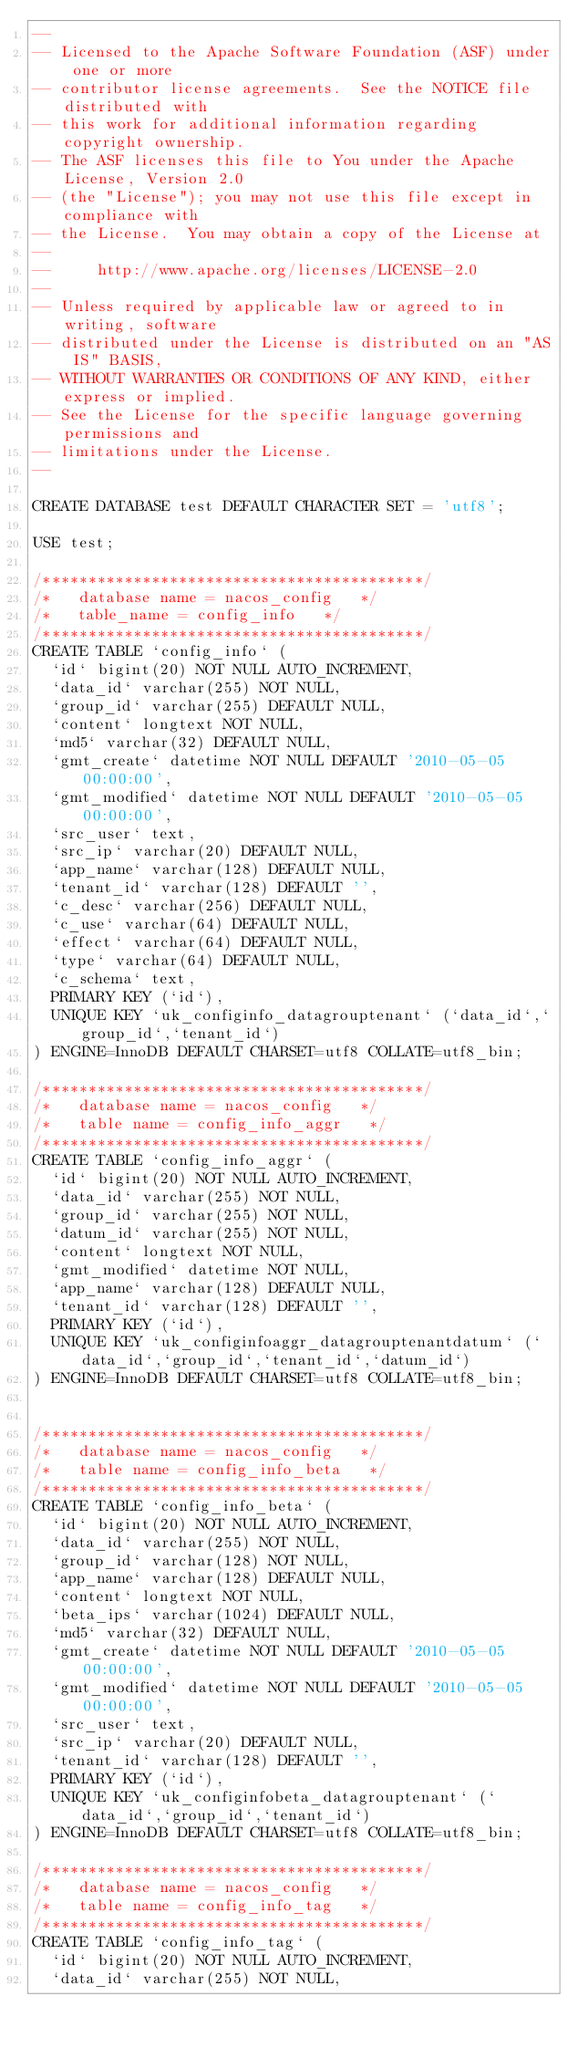<code> <loc_0><loc_0><loc_500><loc_500><_SQL_>--
-- Licensed to the Apache Software Foundation (ASF) under one or more
-- contributor license agreements.  See the NOTICE file distributed with
-- this work for additional information regarding copyright ownership.
-- The ASF licenses this file to You under the Apache License, Version 2.0
-- (the "License"); you may not use this file except in compliance with
-- the License.  You may obtain a copy of the License at
--
--     http://www.apache.org/licenses/LICENSE-2.0
--
-- Unless required by applicable law or agreed to in writing, software
-- distributed under the License is distributed on an "AS IS" BASIS,
-- WITHOUT WARRANTIES OR CONDITIONS OF ANY KIND, either express or implied.
-- See the License for the specific language governing permissions and
-- limitations under the License.
--

CREATE DATABASE test DEFAULT CHARACTER SET = 'utf8';

USE test;

/******************************************/
/*   database name = nacos_config   */
/*   table_name = config_info   */
/******************************************/
CREATE TABLE `config_info` (
  `id` bigint(20) NOT NULL AUTO_INCREMENT,
  `data_id` varchar(255) NOT NULL,
  `group_id` varchar(255) DEFAULT NULL,
  `content` longtext NOT NULL,
  `md5` varchar(32) DEFAULT NULL,
  `gmt_create` datetime NOT NULL DEFAULT '2010-05-05 00:00:00',
  `gmt_modified` datetime NOT NULL DEFAULT '2010-05-05 00:00:00',
  `src_user` text,
  `src_ip` varchar(20) DEFAULT NULL,
  `app_name` varchar(128) DEFAULT NULL,
  `tenant_id` varchar(128) DEFAULT '',
  `c_desc` varchar(256) DEFAULT NULL,
  `c_use` varchar(64) DEFAULT NULL,
  `effect` varchar(64) DEFAULT NULL,
  `type` varchar(64) DEFAULT NULL,
  `c_schema` text,
  PRIMARY KEY (`id`),
  UNIQUE KEY `uk_configinfo_datagrouptenant` (`data_id`,`group_id`,`tenant_id`)
) ENGINE=InnoDB DEFAULT CHARSET=utf8 COLLATE=utf8_bin;

/******************************************/
/*   database name = nacos_config   */
/*   table name = config_info_aggr   */
/******************************************/
CREATE TABLE `config_info_aggr` (
  `id` bigint(20) NOT NULL AUTO_INCREMENT,
  `data_id` varchar(255) NOT NULL,
  `group_id` varchar(255) NOT NULL,
  `datum_id` varchar(255) NOT NULL,
  `content` longtext NOT NULL,
  `gmt_modified` datetime NOT NULL,
  `app_name` varchar(128) DEFAULT NULL,
  `tenant_id` varchar(128) DEFAULT '',
  PRIMARY KEY (`id`),
  UNIQUE KEY `uk_configinfoaggr_datagrouptenantdatum` (`data_id`,`group_id`,`tenant_id`,`datum_id`)
) ENGINE=InnoDB DEFAULT CHARSET=utf8 COLLATE=utf8_bin;


/******************************************/
/*   database name = nacos_config   */
/*   table name = config_info_beta   */
/******************************************/
CREATE TABLE `config_info_beta` (
  `id` bigint(20) NOT NULL AUTO_INCREMENT,
  `data_id` varchar(255) NOT NULL,
  `group_id` varchar(128) NOT NULL,
  `app_name` varchar(128) DEFAULT NULL,
  `content` longtext NOT NULL,
  `beta_ips` varchar(1024) DEFAULT NULL,
  `md5` varchar(32) DEFAULT NULL,
  `gmt_create` datetime NOT NULL DEFAULT '2010-05-05 00:00:00',
  `gmt_modified` datetime NOT NULL DEFAULT '2010-05-05 00:00:00',
  `src_user` text,
  `src_ip` varchar(20) DEFAULT NULL,
  `tenant_id` varchar(128) DEFAULT '',
  PRIMARY KEY (`id`),
  UNIQUE KEY `uk_configinfobeta_datagrouptenant` (`data_id`,`group_id`,`tenant_id`)
) ENGINE=InnoDB DEFAULT CHARSET=utf8 COLLATE=utf8_bin;

/******************************************/
/*   database name = nacos_config   */
/*   table name = config_info_tag   */
/******************************************/
CREATE TABLE `config_info_tag` (
  `id` bigint(20) NOT NULL AUTO_INCREMENT,
  `data_id` varchar(255) NOT NULL,</code> 